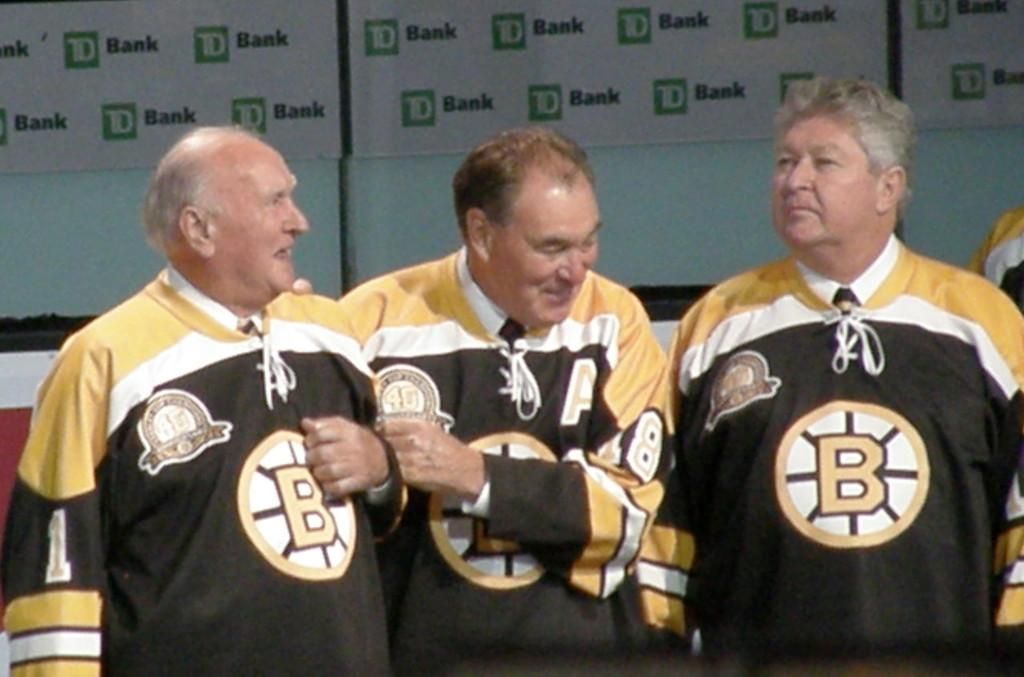Provide a one-sentence caption for the provided image. Three men wearing hockey jerseys in front of a banner sponsored by TD Bank. 